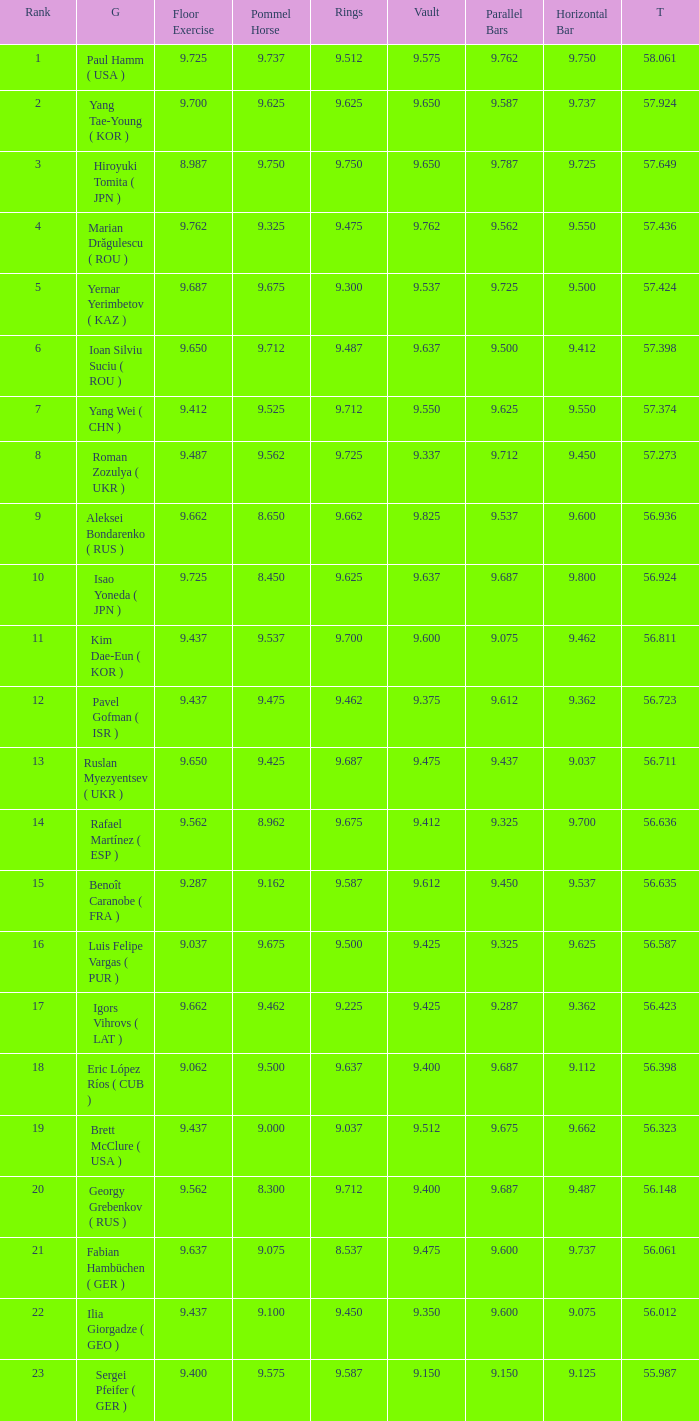What is the vault score for the total of 56.635? 9.612. 